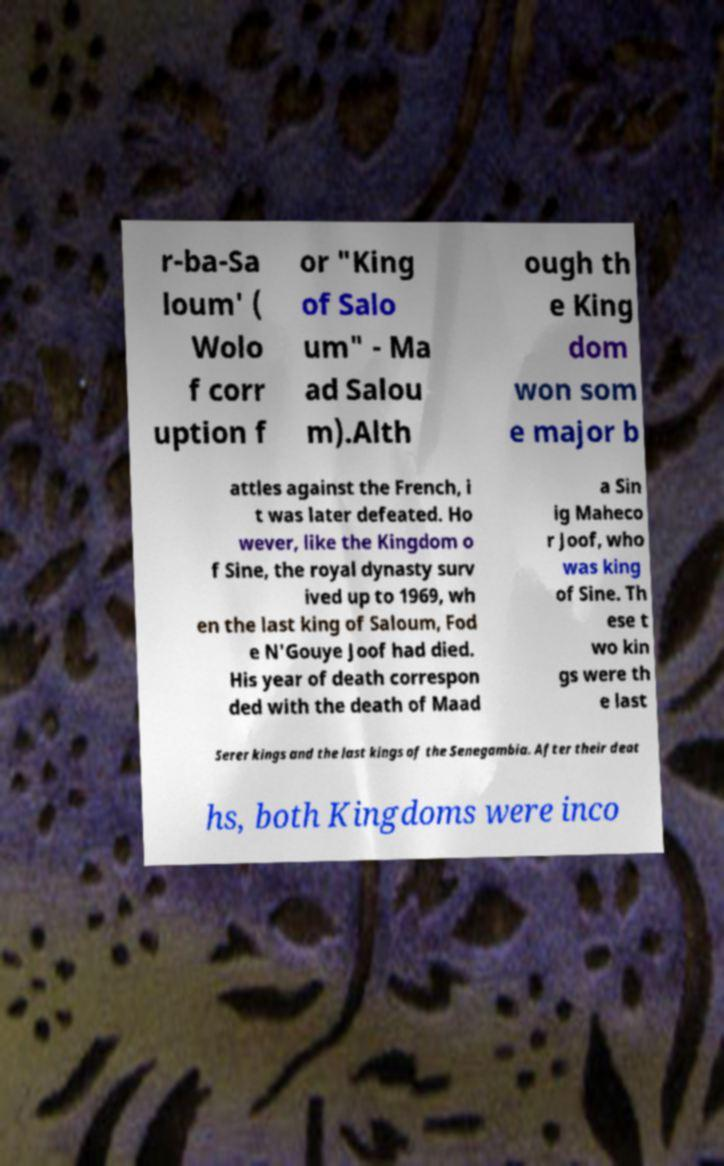What messages or text are displayed in this image? I need them in a readable, typed format. r-ba-Sa loum' ( Wolo f corr uption f or "King of Salo um" - Ma ad Salou m).Alth ough th e King dom won som e major b attles against the French, i t was later defeated. Ho wever, like the Kingdom o f Sine, the royal dynasty surv ived up to 1969, wh en the last king of Saloum, Fod e N'Gouye Joof had died. His year of death correspon ded with the death of Maad a Sin ig Maheco r Joof, who was king of Sine. Th ese t wo kin gs were th e last Serer kings and the last kings of the Senegambia. After their deat hs, both Kingdoms were inco 